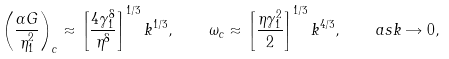<formula> <loc_0><loc_0><loc_500><loc_500>\left ( \frac { \alpha G } { \eta _ { 1 } ^ { 2 } } \right ) _ { c } \approx \left [ \frac { 4 \gamma _ { 1 } ^ { 8 } } { \eta ^ { 8 } } \right ] ^ { 1 / 3 } k ^ { 1 / 3 } , \quad \omega _ { c } \approx \left [ \frac { \eta \gamma _ { 1 } ^ { 2 } } { 2 } \right ] ^ { 1 / 3 } k ^ { 4 / 3 } , \quad a s k \rightarrow 0 ,</formula> 